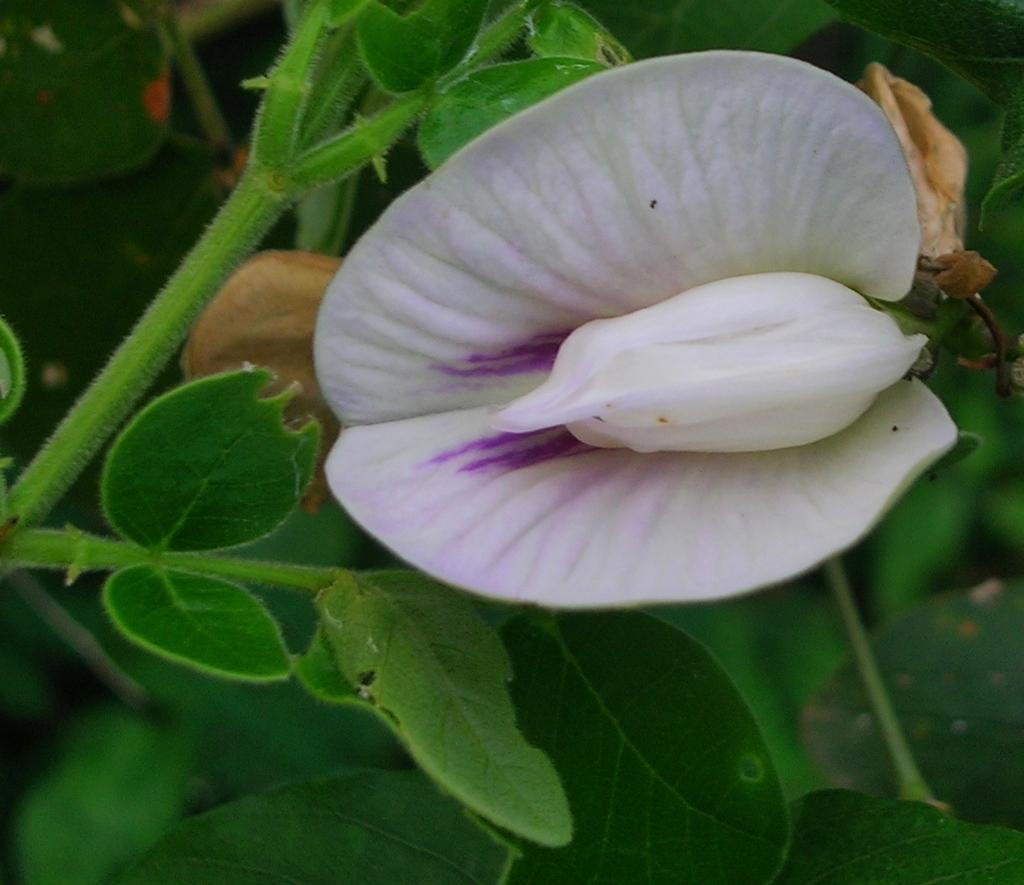What is the main subject of the image? There is a flower in the image. What can be seen in the background of the image? There are leaves visible in the background of the image. What type of property is being discussed in the aftermath of the image? There is no property or aftermath mentioned in the image; it only features a flower and leaves in the background. 